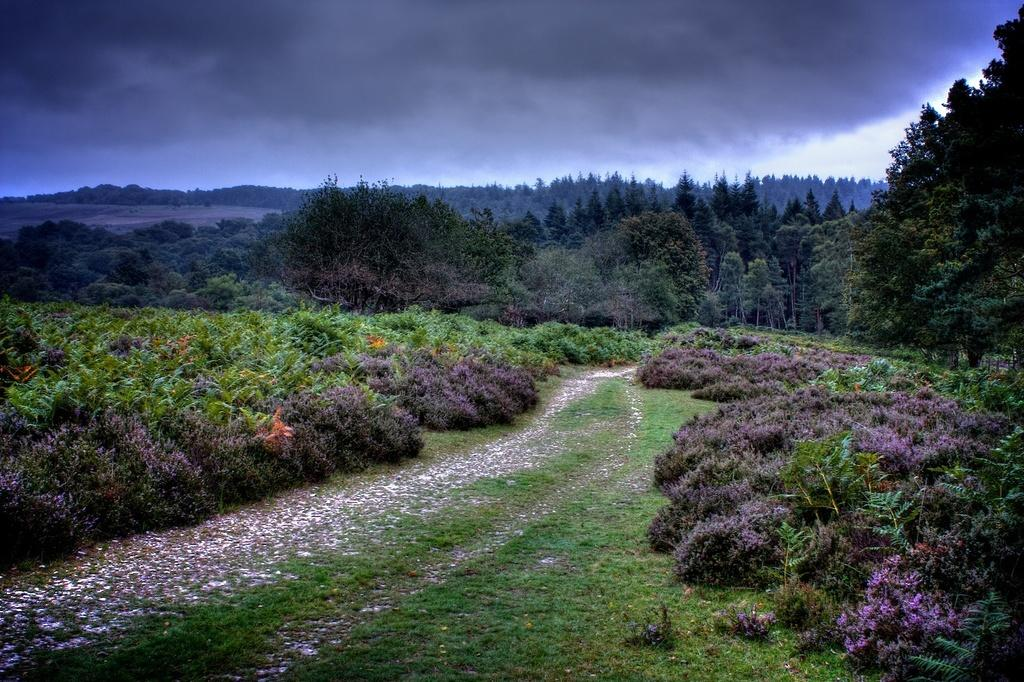Where was the image taken? The image was clicked outside the city. What can be seen in the center of the image? There is green grass in the center of the image. What is visible in the background of the image? There are plants and trees in the background. What is visible at the top of the image? The sky is visible in the image, and it is full of clouds. What type of soap is being used to clean the duck in the image? There is no duck or soap present in the image. What is the pencil being used for in the image? There is no pencil present in the image. 